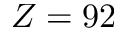Convert formula to latex. <formula><loc_0><loc_0><loc_500><loc_500>Z = 9 2</formula> 